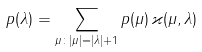<formula> <loc_0><loc_0><loc_500><loc_500>p ( \lambda ) = \sum _ { \mu \colon | \mu | = | \lambda | + 1 } p ( \mu ) \, \varkappa ( \mu , \lambda )</formula> 